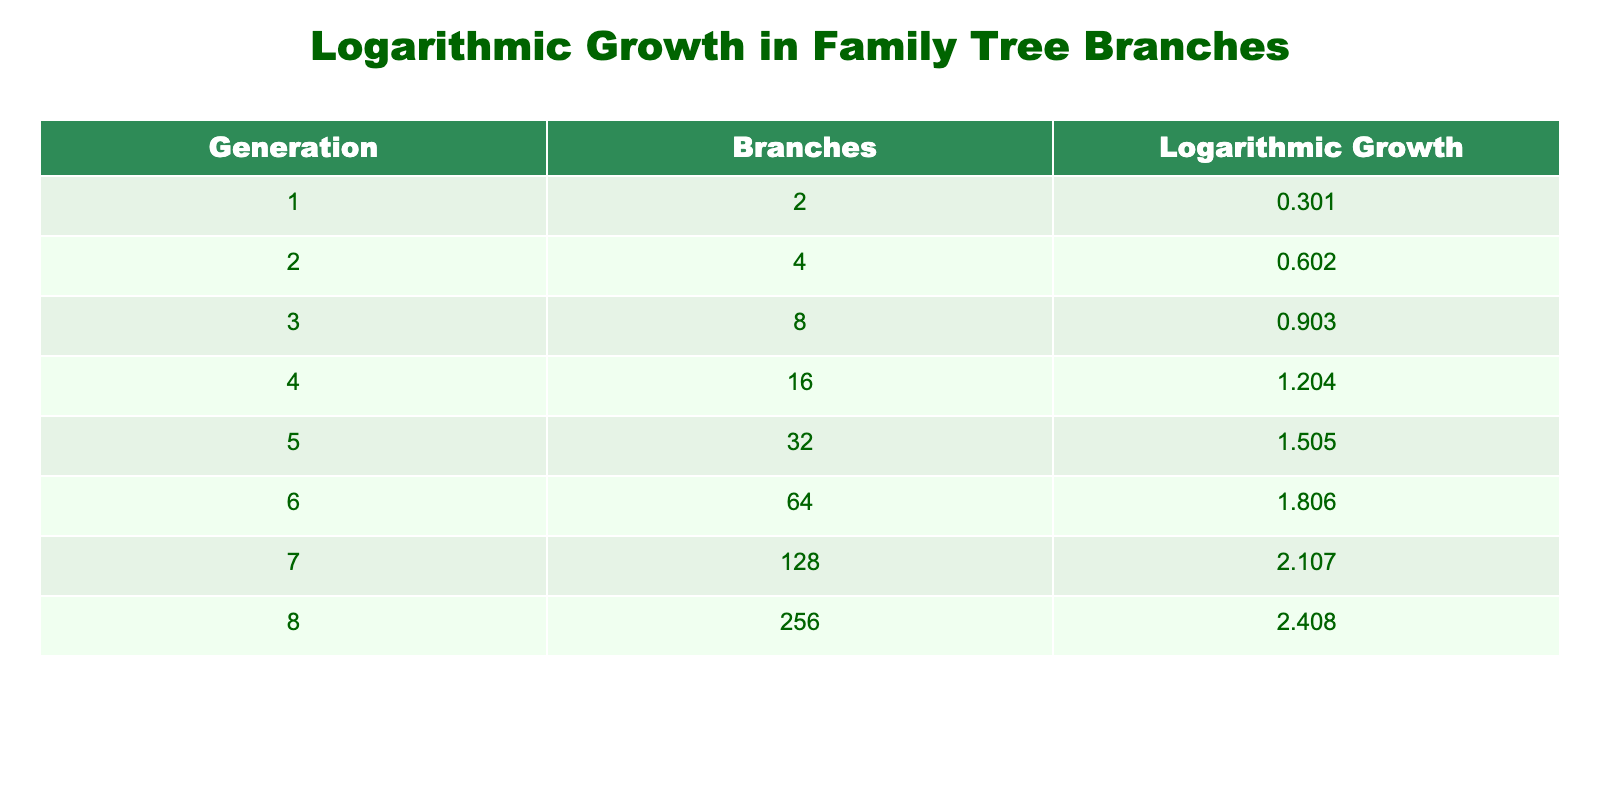What is the number of branches in the first generation? From the table, the value in the “Branches” column for the first generation (1) is 2.
Answer: 2 What is the logarithmic growth of branches in generation 5? The logarithmic growth for the fifth generation (5) is directly given in the table, which is 1.505.
Answer: 1.505 How many branches are there cumulatively from generation 1 to generation 3? To find the cumulative number of branches, we add the values from the “Branches” column for generations 1 (2), 2 (4), and 3 (8): 2 + 4 + 8 = 14.
Answer: 14 Is the number of branches in generation 6 greater than those in generation 4? The number of branches in generation 6 is 64, and for generation 4, it is 16. Since 64 is greater than 16, the answer is yes.
Answer: Yes What is the difference in logarithmic growth between generation 7 and generation 5? The logarithmic growth for generation 7 is 2.107, and for generation 5 it is 1.505. The difference is calculated as: 2.107 - 1.505 = 0.602.
Answer: 0.602 What is the average number of branches from generations 1 to 8? To find the average, first sum the branches: 2 + 4 + 8 + 16 + 32 + 64 + 128 + 256 = 510. There are 8 generations, so the average is 510 / 8 = 63.75.
Answer: 63.75 How many generations have logarithmic growth values less than 1? From the table, generations 1 (0.301), 2 (0.602), and 3 (0.903) have logarithmic growth values less than 1, totaling 3 generations.
Answer: 3 Is there any generation with more than 200 branches? The table shows that generation 8 has 256 branches, which is more than 200. Therefore, the answer is yes.
Answer: Yes What cumulative branches do we see from generation 4 to generation 8? To find the cumulative branches from generations 4 to 8, we total: 16 + 32 + 64 + 128 + 256 = 496.
Answer: 496 